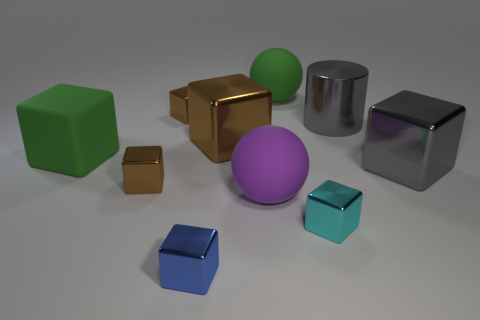There is a cylinder that is the same material as the blue object; what color is it?
Your answer should be very brief. Gray. What number of small blue cylinders are the same material as the green cube?
Your answer should be compact. 0. There is a big ball that is behind the small shiny thing that is behind the green thing left of the big green sphere; what color is it?
Your response must be concise. Green. Is the purple ball the same size as the cyan cube?
Offer a very short reply. No. Is there anything else that has the same shape as the blue shiny object?
Your answer should be very brief. Yes. How many objects are tiny metallic things that are right of the blue shiny thing or tiny blue metal things?
Your response must be concise. 2. Does the small cyan shiny object have the same shape as the big brown thing?
Ensure brevity in your answer.  Yes. What number of other objects are there of the same size as the purple object?
Give a very brief answer. 5. The big matte block is what color?
Provide a short and direct response. Green. How many large things are either shiny blocks or green cylinders?
Offer a very short reply. 2. 